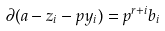<formula> <loc_0><loc_0><loc_500><loc_500>\partial ( a - z _ { i } - p y _ { i } ) = p ^ { r + i } b _ { i }</formula> 